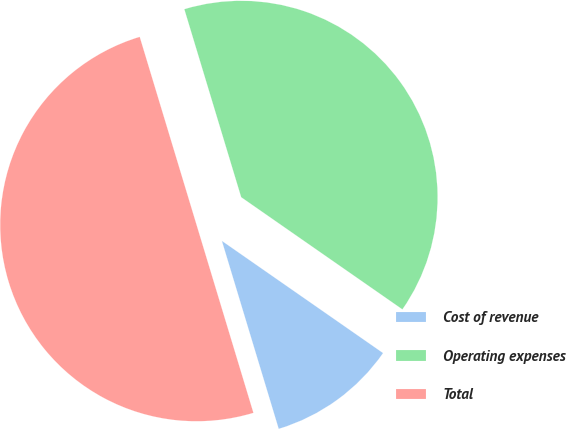Convert chart to OTSL. <chart><loc_0><loc_0><loc_500><loc_500><pie_chart><fcel>Cost of revenue<fcel>Operating expenses<fcel>Total<nl><fcel>10.65%<fcel>39.35%<fcel>50.0%<nl></chart> 